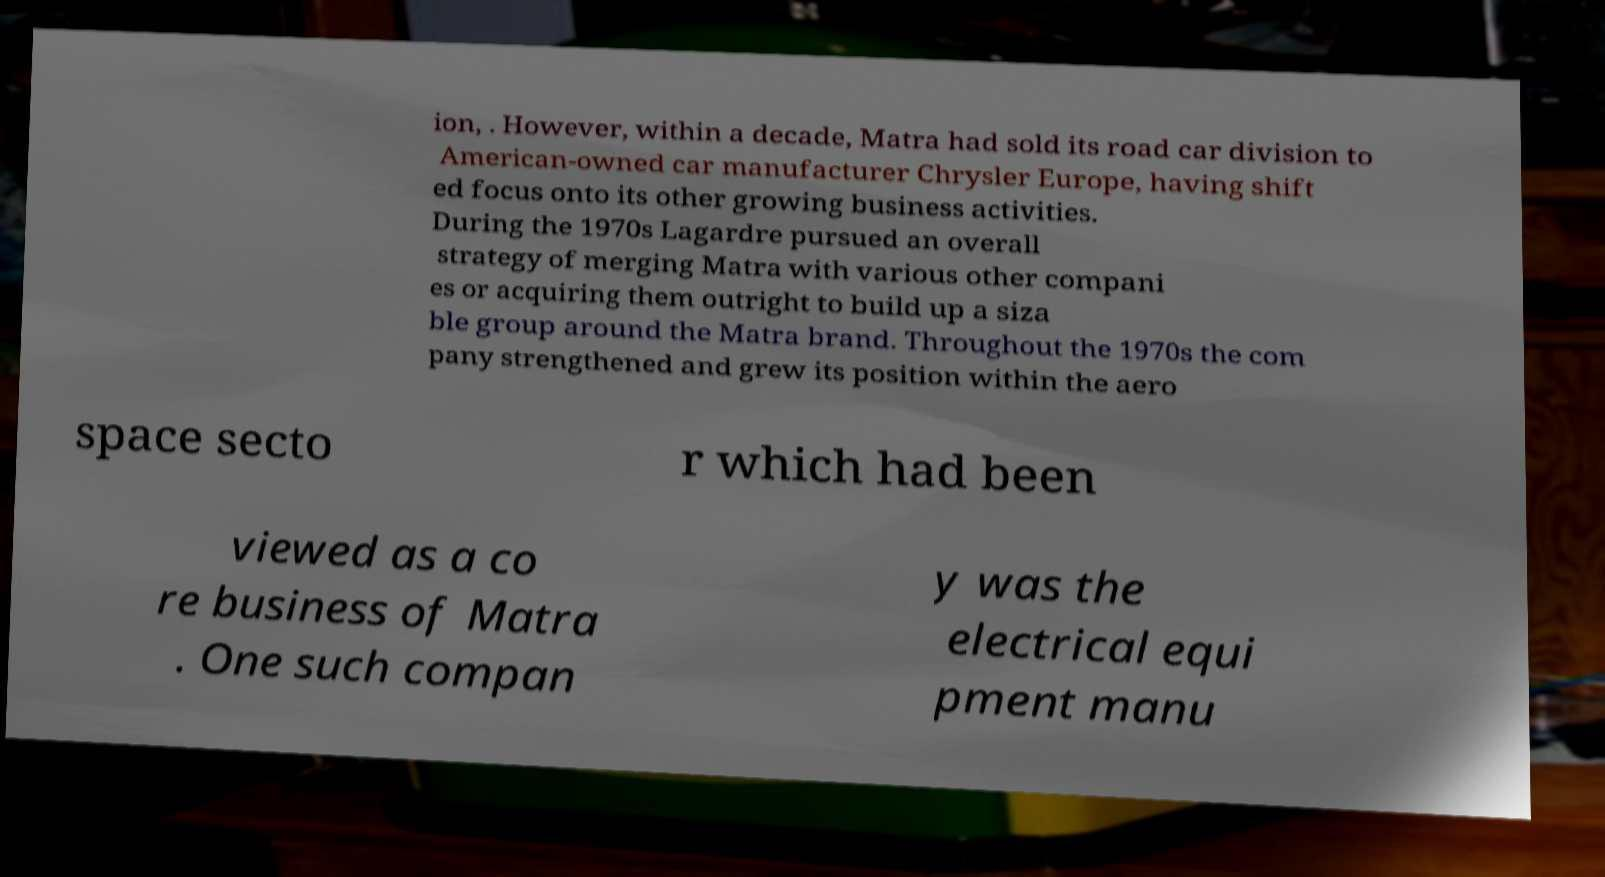Please identify and transcribe the text found in this image. ion, . However, within a decade, Matra had sold its road car division to American-owned car manufacturer Chrysler Europe, having shift ed focus onto its other growing business activities. During the 1970s Lagardre pursued an overall strategy of merging Matra with various other compani es or acquiring them outright to build up a siza ble group around the Matra brand. Throughout the 1970s the com pany strengthened and grew its position within the aero space secto r which had been viewed as a co re business of Matra . One such compan y was the electrical equi pment manu 